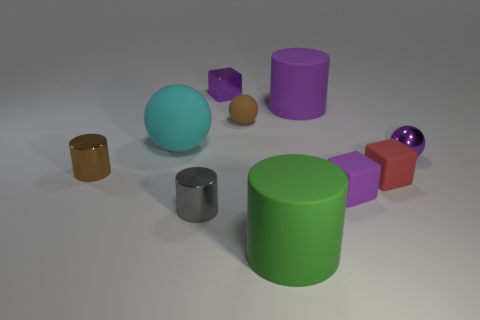What size is the matte cylinder that is the same color as the tiny shiny sphere?
Your answer should be very brief. Large. What is the shape of the small thing that is the same color as the small matte sphere?
Ensure brevity in your answer.  Cylinder. What material is the tiny block to the left of the green cylinder?
Ensure brevity in your answer.  Metal. Does the green rubber thing have the same shape as the tiny red matte thing?
Provide a succinct answer. No. What color is the metal object right of the purple shiny thing to the left of the matte cylinder in front of the small brown ball?
Keep it short and to the point. Purple. How many other gray things have the same shape as the small gray object?
Your answer should be compact. 0. There is a cylinder that is behind the tiny brown object in front of the tiny matte ball; what size is it?
Provide a short and direct response. Large. Is the size of the green matte object the same as the metal ball?
Offer a terse response. No. Is there a small purple block that is on the left side of the shiny object that is right of the small purple thing behind the small metallic sphere?
Your answer should be compact. Yes. The cyan matte ball is what size?
Your answer should be compact. Large. 